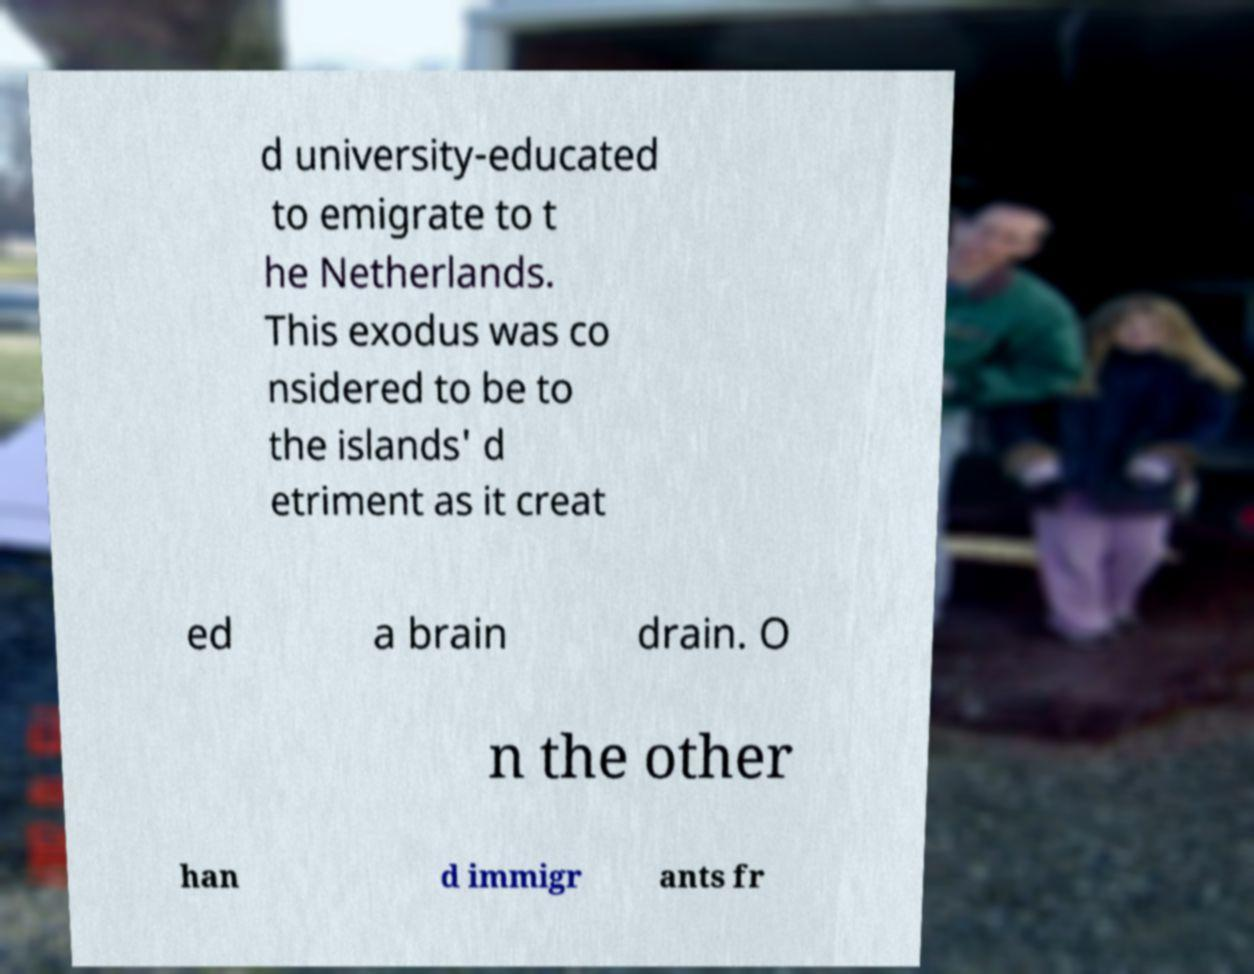Could you assist in decoding the text presented in this image and type it out clearly? d university-educated to emigrate to t he Netherlands. This exodus was co nsidered to be to the islands' d etriment as it creat ed a brain drain. O n the other han d immigr ants fr 